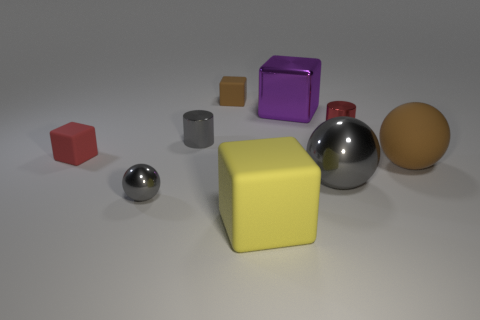Subtract all gray spheres. How many were subtracted if there are1gray spheres left? 1 Add 1 cyan metal things. How many objects exist? 10 Subtract all large spheres. How many spheres are left? 1 Subtract all red cubes. How many gray spheres are left? 2 Subtract all cylinders. How many objects are left? 7 Subtract all purple cubes. How many cubes are left? 3 Subtract 1 balls. How many balls are left? 2 Subtract all green blocks. Subtract all yellow cylinders. How many blocks are left? 4 Subtract all brown matte blocks. Subtract all big things. How many objects are left? 4 Add 8 small red shiny things. How many small red shiny things are left? 9 